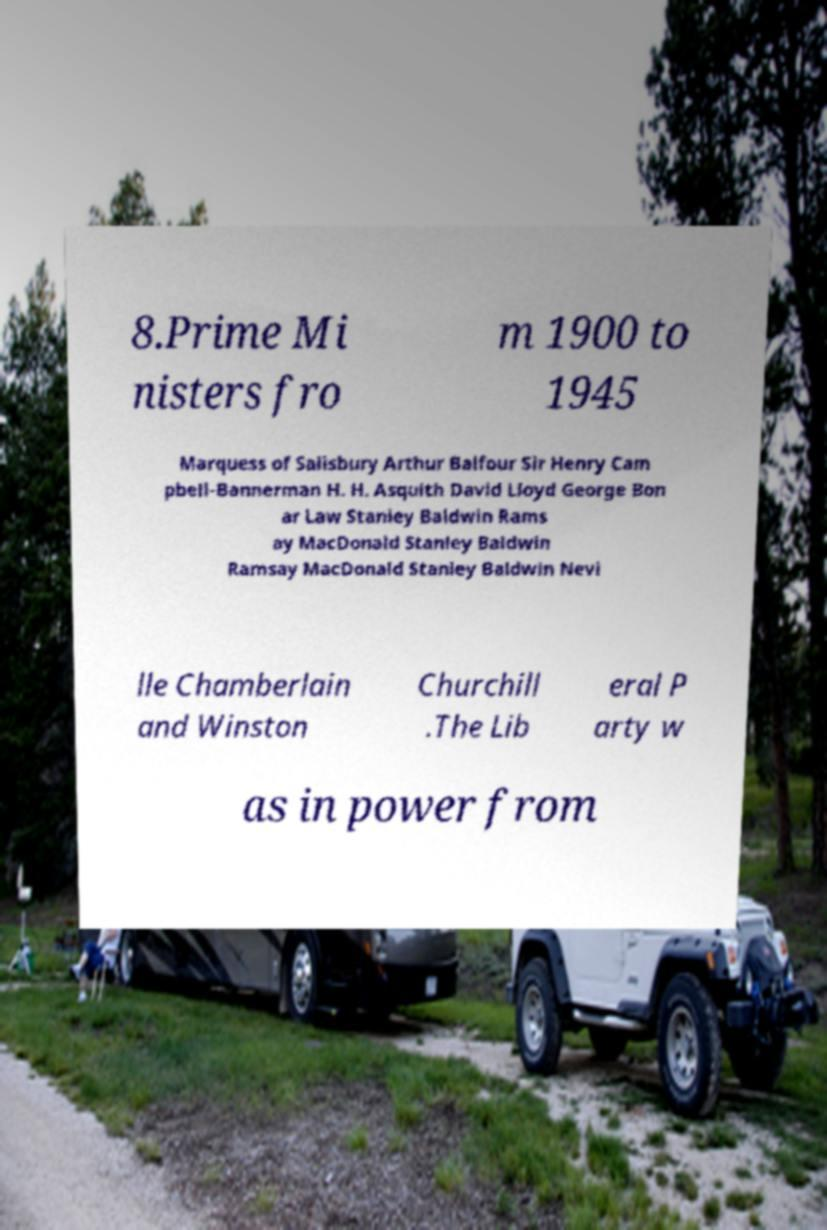I need the written content from this picture converted into text. Can you do that? 8.Prime Mi nisters fro m 1900 to 1945 Marquess of Salisbury Arthur Balfour Sir Henry Cam pbell-Bannerman H. H. Asquith David Lloyd George Bon ar Law Stanley Baldwin Rams ay MacDonald Stanley Baldwin Ramsay MacDonald Stanley Baldwin Nevi lle Chamberlain and Winston Churchill .The Lib eral P arty w as in power from 